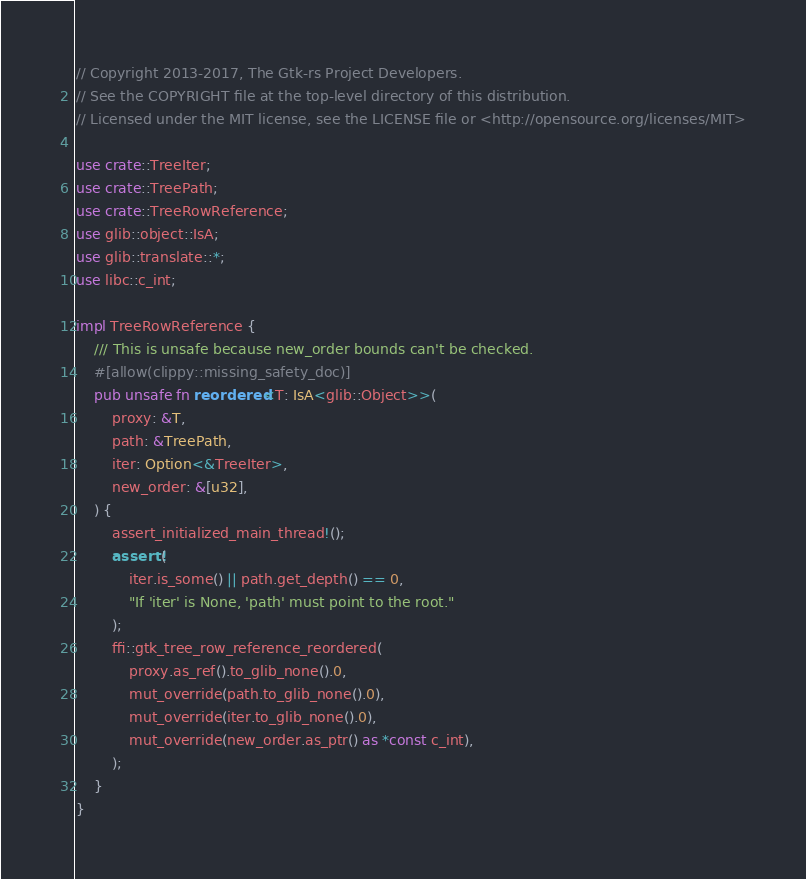<code> <loc_0><loc_0><loc_500><loc_500><_Rust_>// Copyright 2013-2017, The Gtk-rs Project Developers.
// See the COPYRIGHT file at the top-level directory of this distribution.
// Licensed under the MIT license, see the LICENSE file or <http://opensource.org/licenses/MIT>

use crate::TreeIter;
use crate::TreePath;
use crate::TreeRowReference;
use glib::object::IsA;
use glib::translate::*;
use libc::c_int;

impl TreeRowReference {
    /// This is unsafe because new_order bounds can't be checked.
    #[allow(clippy::missing_safety_doc)]
    pub unsafe fn reordered<T: IsA<glib::Object>>(
        proxy: &T,
        path: &TreePath,
        iter: Option<&TreeIter>,
        new_order: &[u32],
    ) {
        assert_initialized_main_thread!();
        assert!(
            iter.is_some() || path.get_depth() == 0,
            "If 'iter' is None, 'path' must point to the root."
        );
        ffi::gtk_tree_row_reference_reordered(
            proxy.as_ref().to_glib_none().0,
            mut_override(path.to_glib_none().0),
            mut_override(iter.to_glib_none().0),
            mut_override(new_order.as_ptr() as *const c_int),
        );
    }
}
</code> 